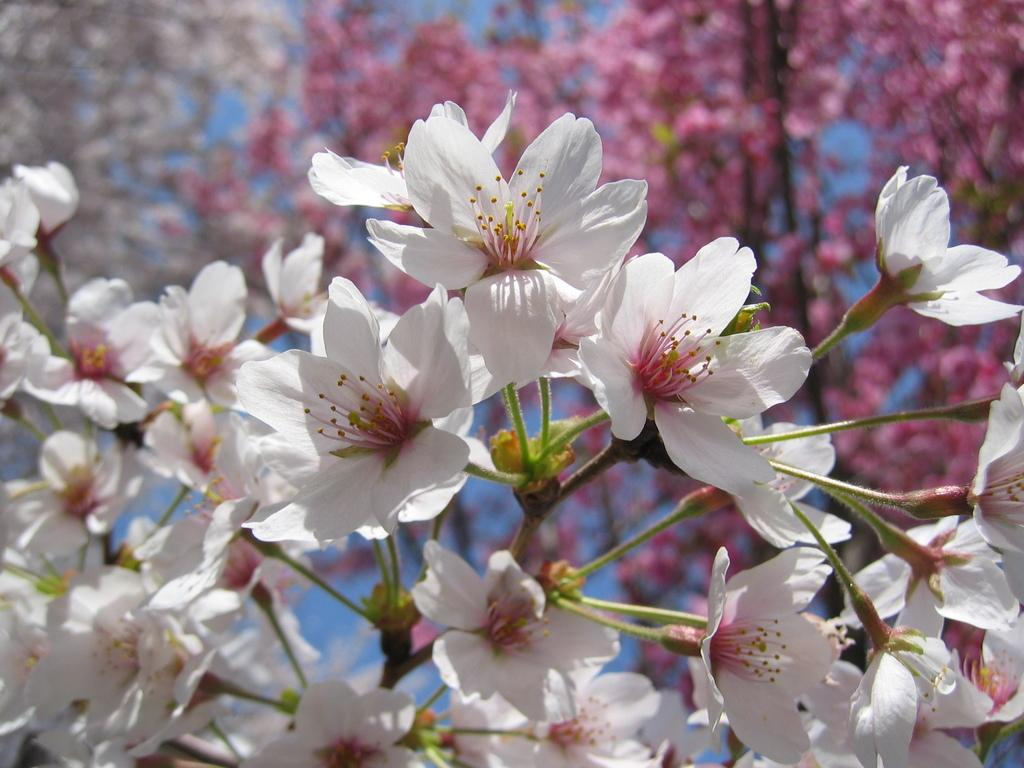What type of living organisms are in the image? There are flowers in the image. What colors are the flowers? The flowers are white and pink in color. Where are the flowers located? The flowers are on a plant. What color is the plant? The plant is green in color. What can be seen in the background of the image? Trees and the sky are visible in the background of the image. What year is depicted in the image? The image does not depict a specific year; it is a photograph of flowers, a plant, trees, and the sky. Can you tell me how many churches are visible in the image? There are no churches present in the image; it features flowers, a plant, trees, and the sky. 